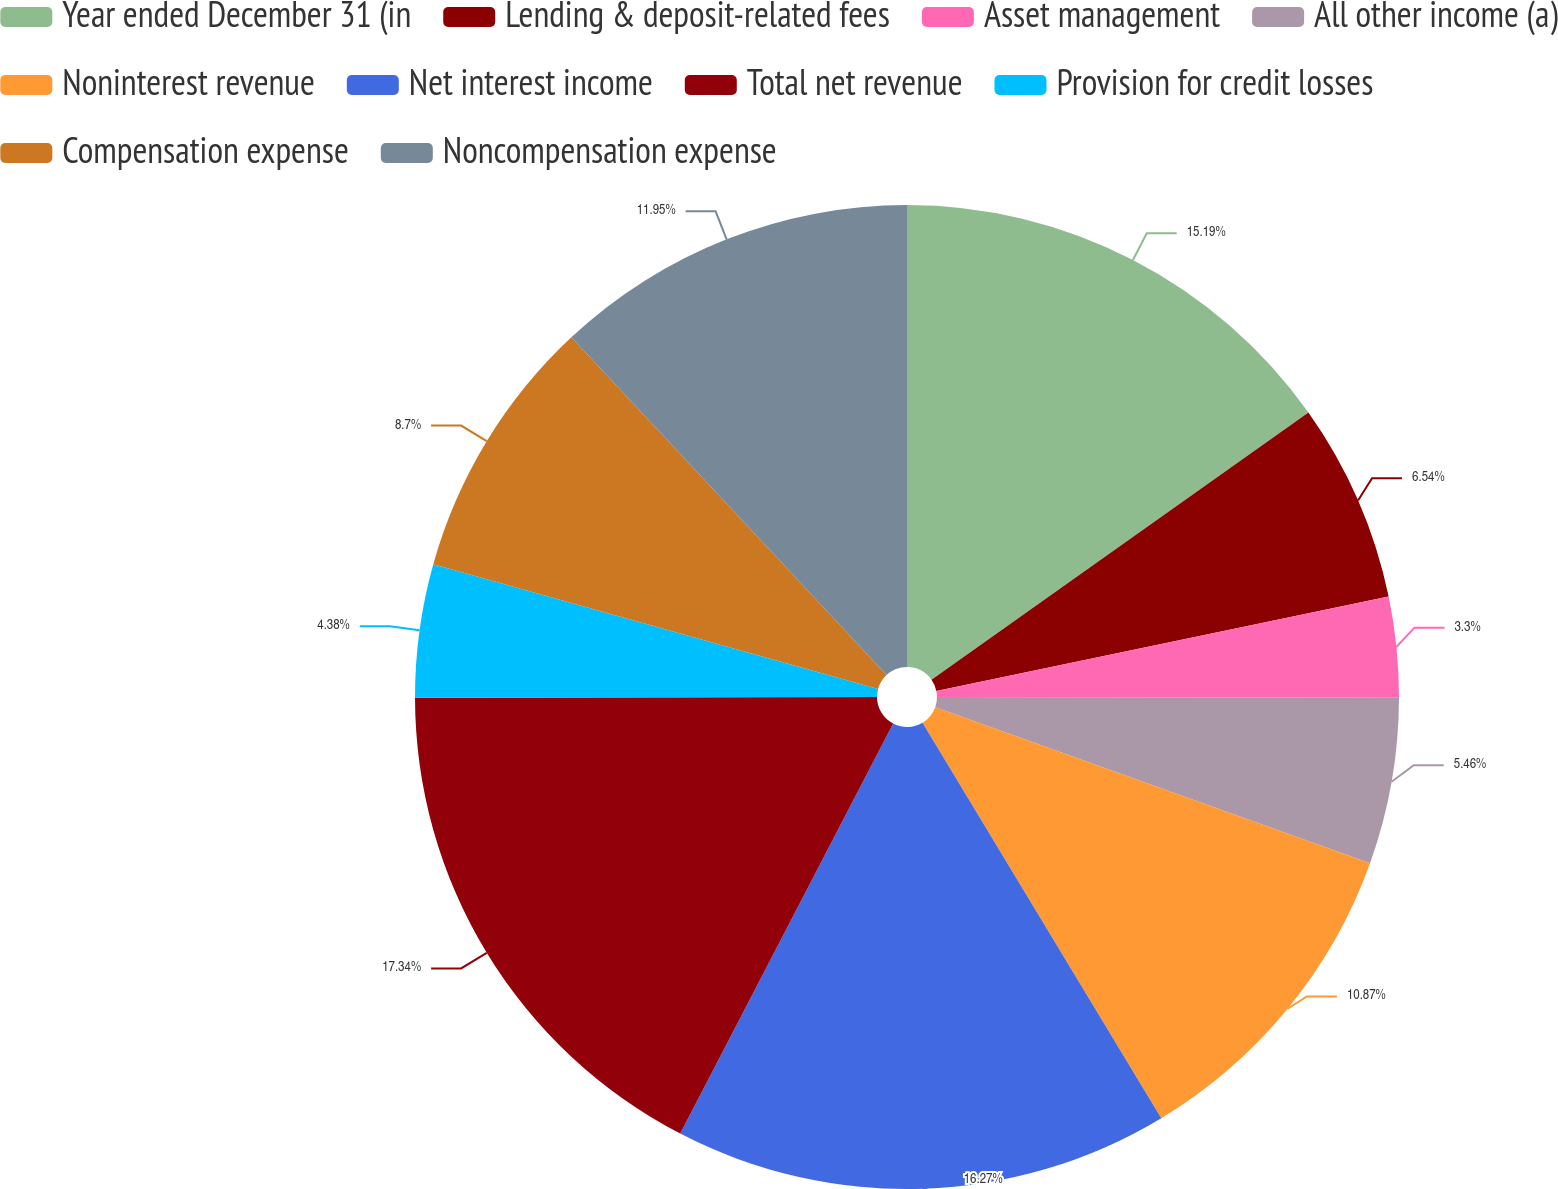<chart> <loc_0><loc_0><loc_500><loc_500><pie_chart><fcel>Year ended December 31 (in<fcel>Lending & deposit-related fees<fcel>Asset management<fcel>All other income (a)<fcel>Noninterest revenue<fcel>Net interest income<fcel>Total net revenue<fcel>Provision for credit losses<fcel>Compensation expense<fcel>Noncompensation expense<nl><fcel>15.19%<fcel>6.54%<fcel>3.3%<fcel>5.46%<fcel>10.87%<fcel>16.27%<fcel>17.35%<fcel>4.38%<fcel>8.7%<fcel>11.95%<nl></chart> 